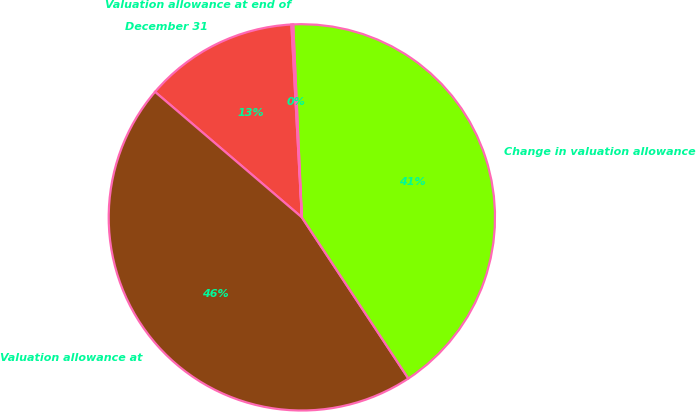Convert chart. <chart><loc_0><loc_0><loc_500><loc_500><pie_chart><fcel>December 31<fcel>Valuation allowance at<fcel>Change in valuation allowance<fcel>Valuation allowance at end of<nl><fcel>12.88%<fcel>45.55%<fcel>41.41%<fcel>0.15%<nl></chart> 